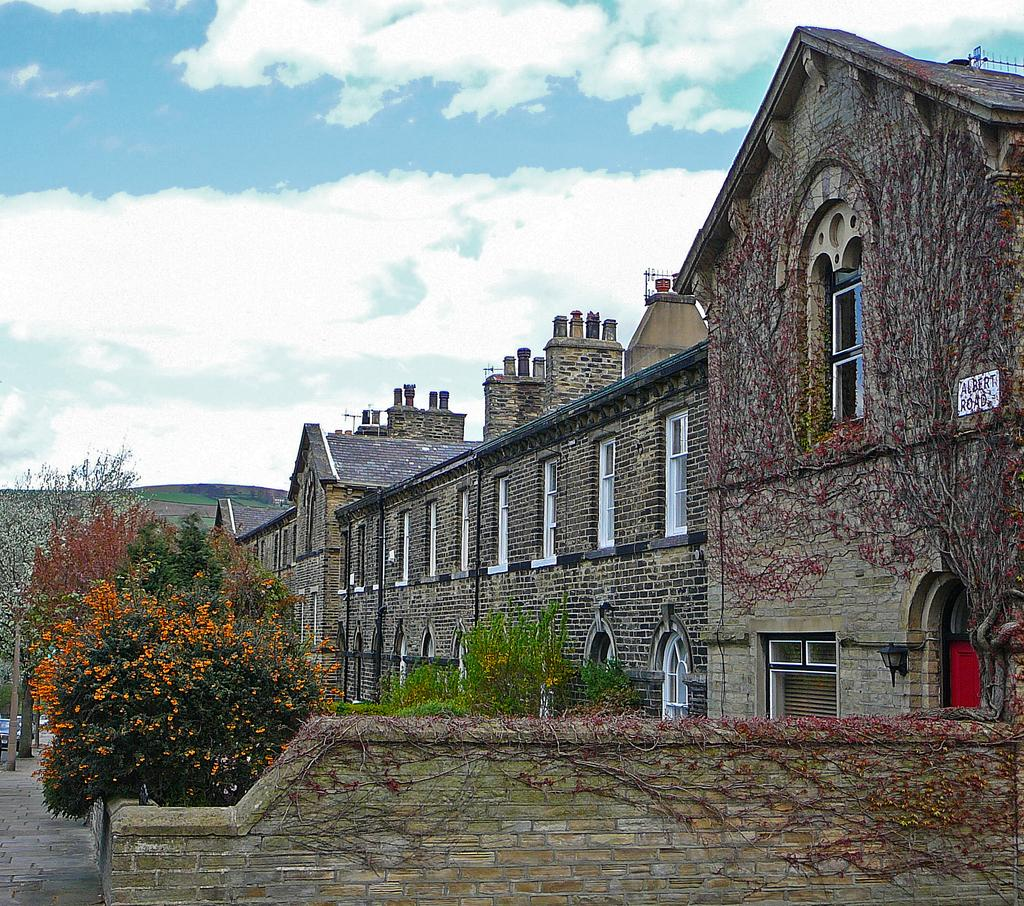What type of structure is present in the image? There is a building in the image. What can be seen on the left side of the image? There is a group of trees on the left side of the image. What is parked on the road in the image? A vehicle is parked on the road. What is visible in the background of the image? There is a mountain and a cloudy sky visible in the background. How many pieces of paper are scattered around the visitor in the image? There is no visitor or paper present in the image. What type of cloud is floating above the mountain in the image? There is no specific type of cloud mentioned in the image; the sky is simply described as cloudy. 